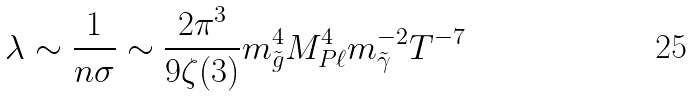<formula> <loc_0><loc_0><loc_500><loc_500>\lambda \sim \frac { 1 } { n \sigma } \sim \frac { 2 \pi ^ { 3 } } { 9 \zeta ( 3 ) } m _ { \tilde { g } } ^ { 4 } M _ { P \ell } ^ { 4 } m _ { \tilde { \gamma } } ^ { - 2 } T ^ { - 7 }</formula> 